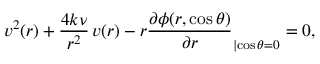<formula> <loc_0><loc_0><loc_500><loc_500>v ^ { 2 } ( r ) + \frac { 4 k \nu } { r ^ { 2 } } \, v ( r ) - r \frac { \partial \phi ( r , \cos \theta ) } { \partial r } _ { | { \cos \theta = 0 } } = 0 ,</formula> 